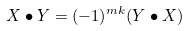Convert formula to latex. <formula><loc_0><loc_0><loc_500><loc_500>X \bullet Y = ( - 1 ) ^ { m k } ( Y \bullet X )</formula> 